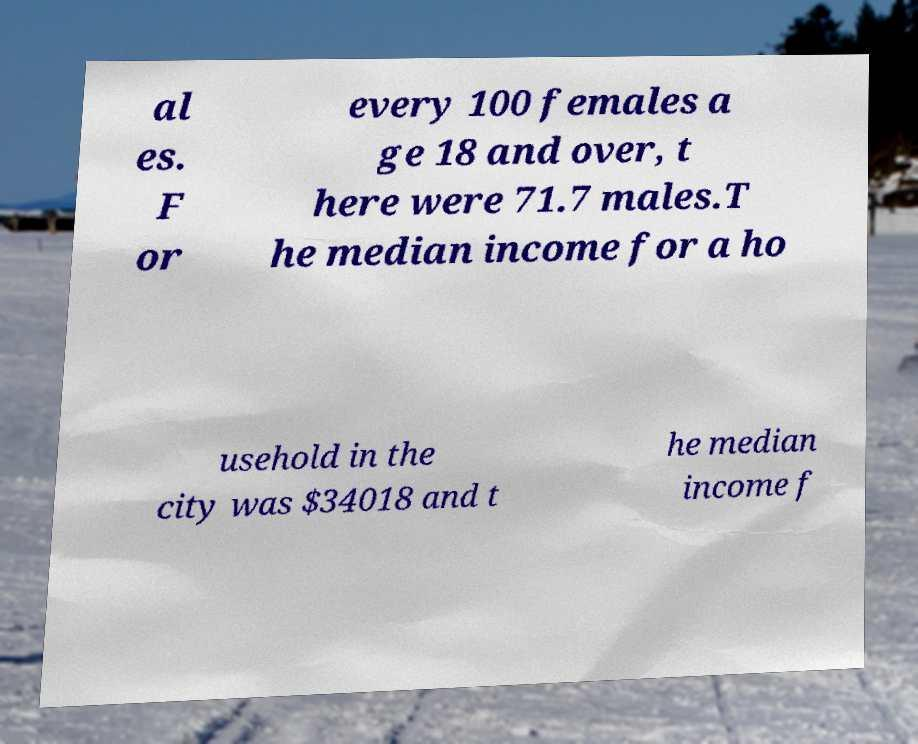For documentation purposes, I need the text within this image transcribed. Could you provide that? al es. F or every 100 females a ge 18 and over, t here were 71.7 males.T he median income for a ho usehold in the city was $34018 and t he median income f 